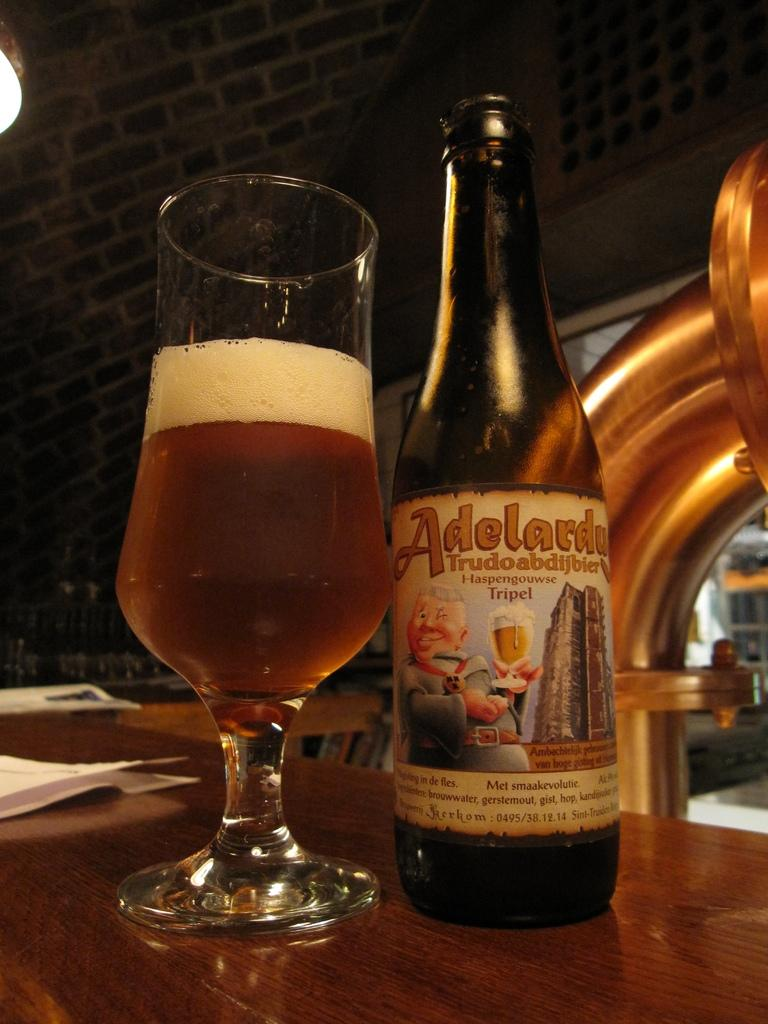<image>
Summarize the visual content of the image. A beer bottle that says Adelardy is next to a half full glass. 